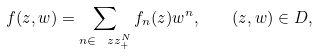Convert formula to latex. <formula><loc_0><loc_0><loc_500><loc_500>f ( z , w ) = \sum _ { n \in \ z z _ { + } ^ { N } } f _ { n } ( z ) w ^ { n } , \quad ( z , w ) \in D ,</formula> 